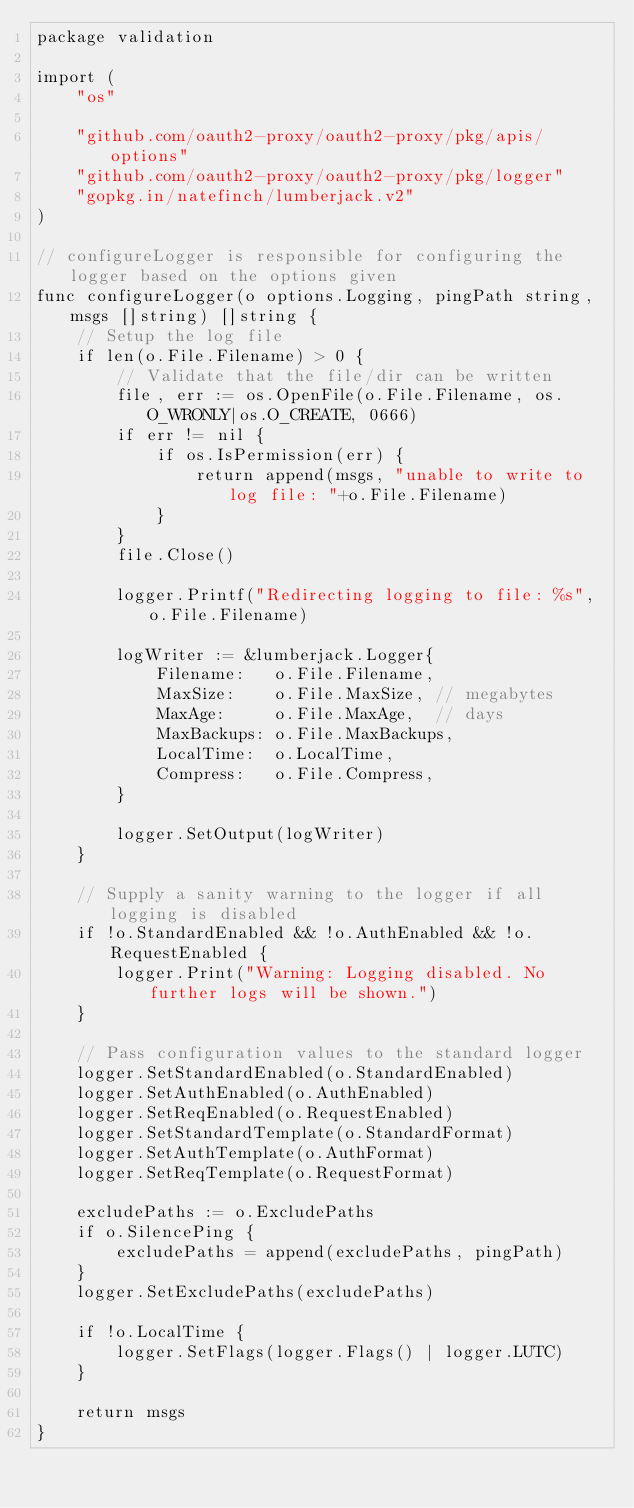Convert code to text. <code><loc_0><loc_0><loc_500><loc_500><_Go_>package validation

import (
	"os"

	"github.com/oauth2-proxy/oauth2-proxy/pkg/apis/options"
	"github.com/oauth2-proxy/oauth2-proxy/pkg/logger"
	"gopkg.in/natefinch/lumberjack.v2"
)

// configureLogger is responsible for configuring the logger based on the options given
func configureLogger(o options.Logging, pingPath string, msgs []string) []string {
	// Setup the log file
	if len(o.File.Filename) > 0 {
		// Validate that the file/dir can be written
		file, err := os.OpenFile(o.File.Filename, os.O_WRONLY|os.O_CREATE, 0666)
		if err != nil {
			if os.IsPermission(err) {
				return append(msgs, "unable to write to log file: "+o.File.Filename)
			}
		}
		file.Close()

		logger.Printf("Redirecting logging to file: %s", o.File.Filename)

		logWriter := &lumberjack.Logger{
			Filename:   o.File.Filename,
			MaxSize:    o.File.MaxSize, // megabytes
			MaxAge:     o.File.MaxAge,  // days
			MaxBackups: o.File.MaxBackups,
			LocalTime:  o.LocalTime,
			Compress:   o.File.Compress,
		}

		logger.SetOutput(logWriter)
	}

	// Supply a sanity warning to the logger if all logging is disabled
	if !o.StandardEnabled && !o.AuthEnabled && !o.RequestEnabled {
		logger.Print("Warning: Logging disabled. No further logs will be shown.")
	}

	// Pass configuration values to the standard logger
	logger.SetStandardEnabled(o.StandardEnabled)
	logger.SetAuthEnabled(o.AuthEnabled)
	logger.SetReqEnabled(o.RequestEnabled)
	logger.SetStandardTemplate(o.StandardFormat)
	logger.SetAuthTemplate(o.AuthFormat)
	logger.SetReqTemplate(o.RequestFormat)

	excludePaths := o.ExcludePaths
	if o.SilencePing {
		excludePaths = append(excludePaths, pingPath)
	}
	logger.SetExcludePaths(excludePaths)

	if !o.LocalTime {
		logger.SetFlags(logger.Flags() | logger.LUTC)
	}

	return msgs
}
</code> 